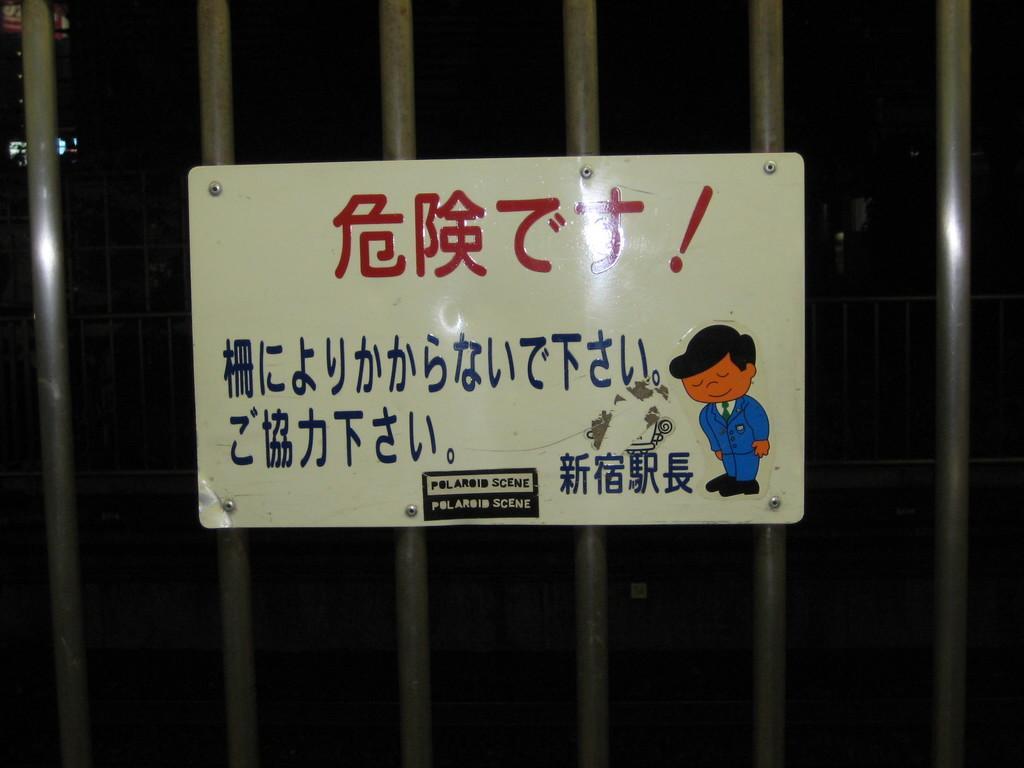Can you describe this image briefly? In the image we can see some poles, on the poles there is a sign board. 